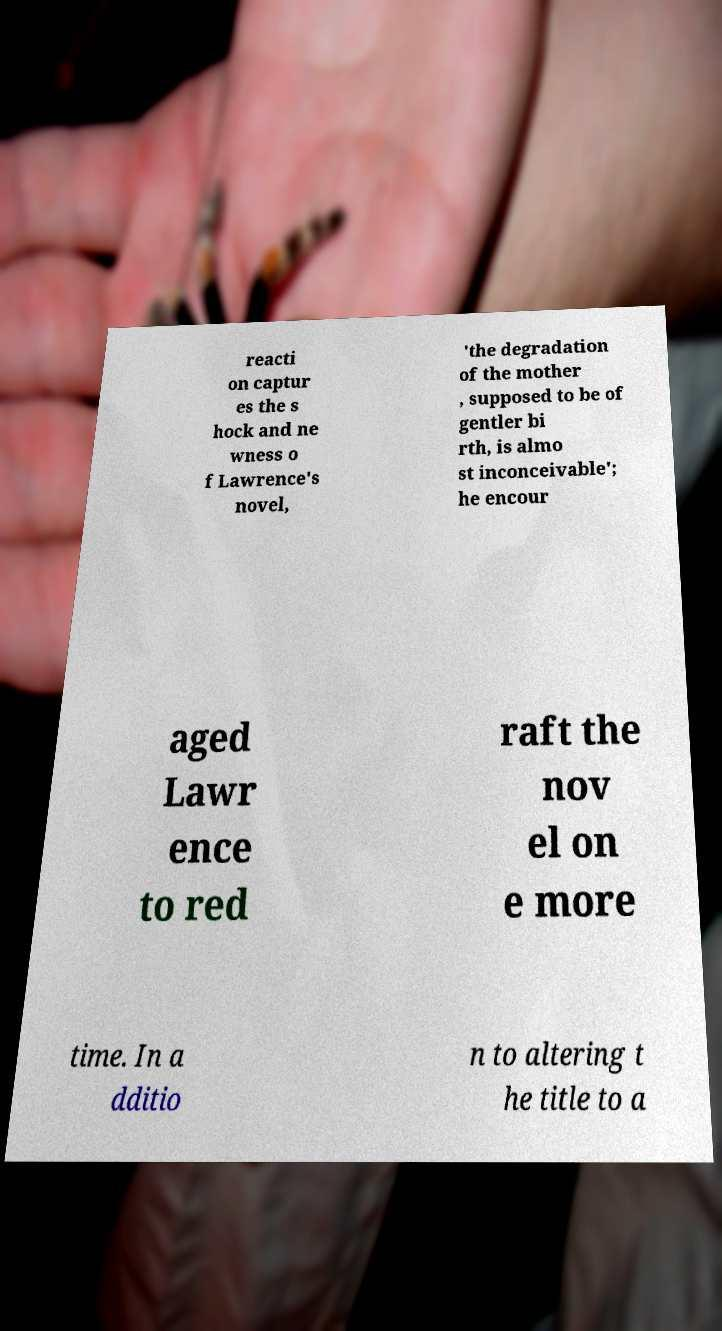Please read and relay the text visible in this image. What does it say? reacti on captur es the s hock and ne wness o f Lawrence's novel, 'the degradation of the mother , supposed to be of gentler bi rth, is almo st inconceivable'; he encour aged Lawr ence to red raft the nov el on e more time. In a dditio n to altering t he title to a 